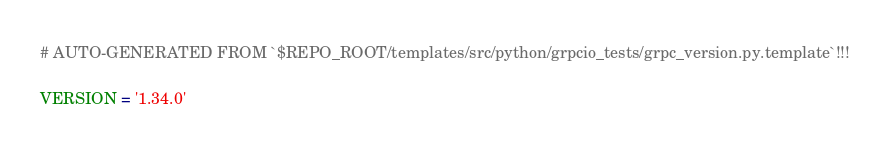<code> <loc_0><loc_0><loc_500><loc_500><_Python_># AUTO-GENERATED FROM `$REPO_ROOT/templates/src/python/grpcio_tests/grpc_version.py.template`!!!

VERSION = '1.34.0'
</code> 